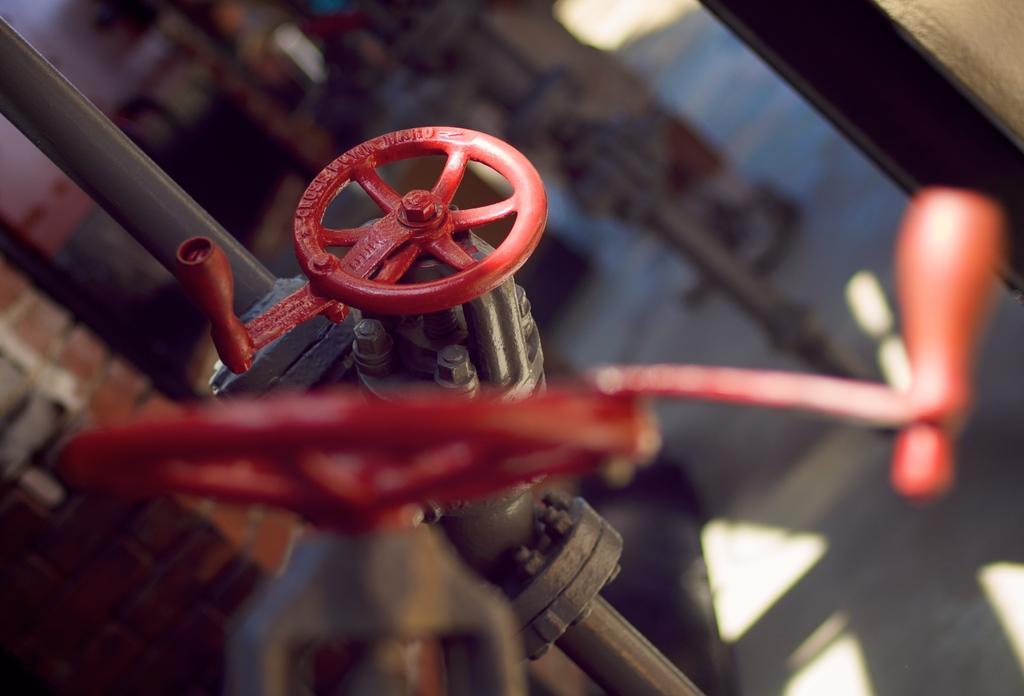Describe this image in one or two sentences. In the picture I can see red color taps fixed to the pipe and this part of the image is blurred and the background of the image is also blurred. 